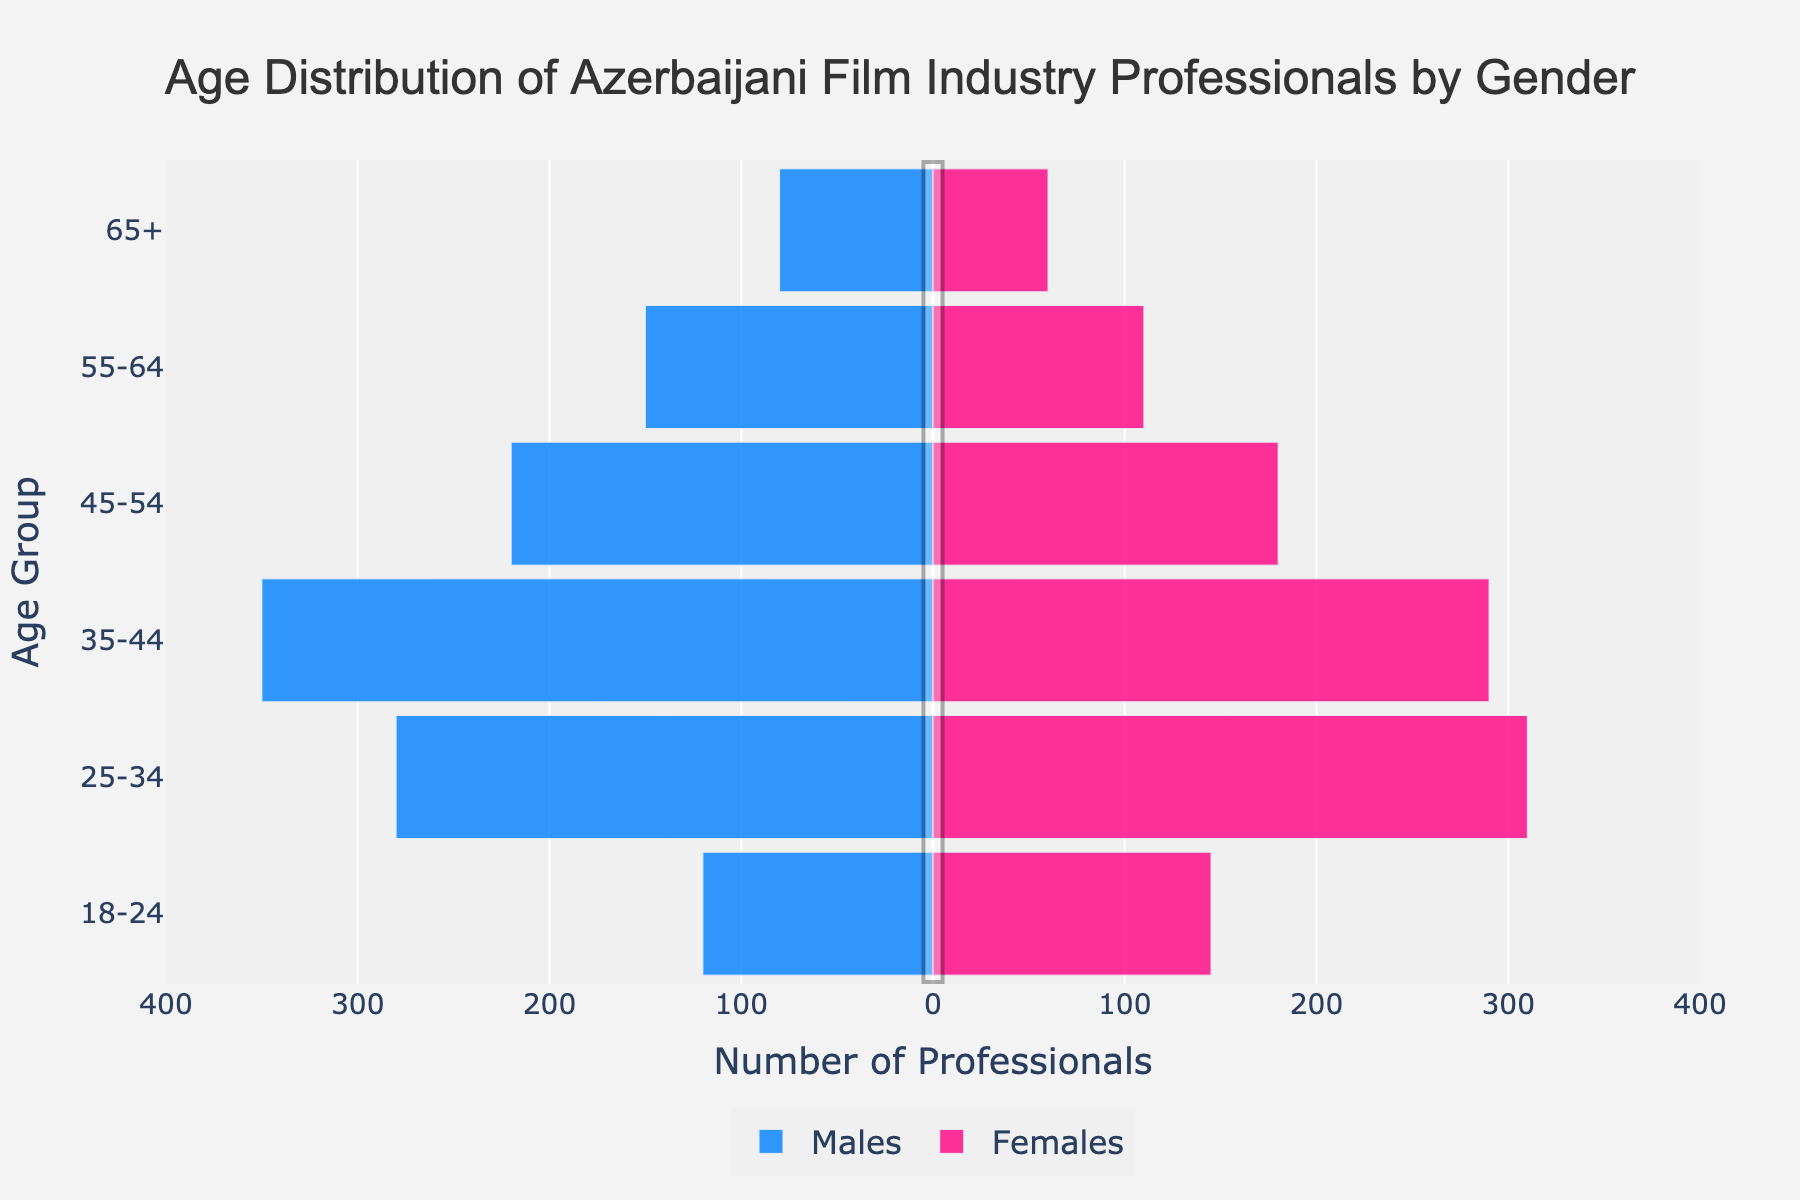What is the title of the plot? The plot's title is placed at the top and details the subject of the visualization. Reading it carefully gives us the title.
Answer: Age Distribution of Azerbaijani Film Industry Professionals by Gender What age group has the highest number of male professionals? Observing the length of the horizontal blue bars, the age group with the longest blue bar has the highest number of male professionals.
Answer: 35-44 Which age group has more female professionals compared to males? Comparing the pink and blue bars for each age group, any age group where the pink bar is longer than the blue indicates more female professionals.
Answer: 18-24 What is the trend in the number of professionals as age increases? Observe the lengths of both blue and pink bars across age groups from left to right. The general trend declines as the age increases.
Answer: Declines How many more female professionals are there than male professionals in the 25-34 age group? Subtract the number of male professionals from the number of female professionals in the 25-34 age group.
Answer: 30 Which age group has the smallest gap between the number of male and female professionals? Calculate the absolute difference between male and female professionals in each age group and identify the smallest value.
Answer: 35-44 In which age group is the total number of professionals (males plus females) the highest? Add up the values of male and female professionals for each age group and find the maximum.
Answer: 35-44 What is the total number of professionals in the 45-54 age group? Sum the number of male and female professionals in the 45-54 age group.
Answer: 400 What percentage of the total number of male professionals are in the 25-34 age group? Divide the number of males in the 25-34 age group by the total number of male professionals and multiply by 100.
Answer: 30% Is the gender distribution more balanced in younger or older age groups? Compare the differences in the lengths of the blue and pink bars for younger and older age groups.
Answer: Younger 